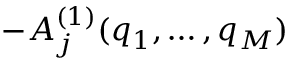Convert formula to latex. <formula><loc_0><loc_0><loc_500><loc_500>- A _ { j } ^ { ( 1 ) } ( q _ { 1 } , \dots , q _ { M } )</formula> 